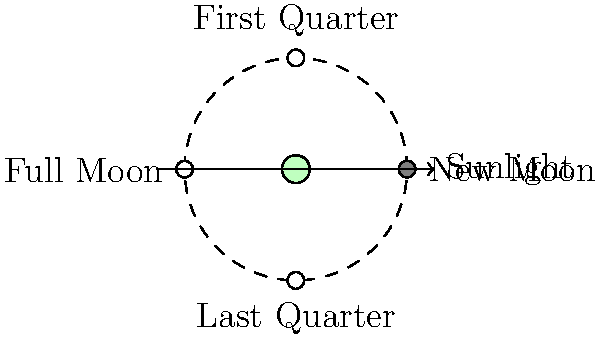As you observe the night sky and connect with the natural rhythms of the Earth, you notice the changing phases of the moon. Based on the diagram, which phase of the moon would occur when the Earth is positioned between the Sun and the Moon? To answer this question, let's break down the moon phases and their relationship to Earth's position:

1. The diagram shows four main phases of the moon: New Moon, First Quarter, Full Moon, and Last Quarter.

2. The arrow on the right indicates the direction of sunlight.

3. The Earth is at the center of the diagram, with the moon's orbit shown as a dashed circle around it.

4. The moon's position relative to Earth and the Sun determines its phase:

   a. New Moon: The moon is between Earth and the Sun, with its dark side facing Earth.
   b. First Quarter: The moon is at a 90-degree angle to the Earth-Sun line, with half of its visible side illuminated.
   c. Full Moon: The Earth is between the Sun and the Moon, with the moon's fully illuminated side facing Earth.
   d. Last Quarter: The moon is again at a 90-degree angle, but on the opposite side from the First Quarter.

5. When the Earth is positioned between the Sun and the Moon, the Sun's light fully illuminates the side of the moon facing Earth.

6. This configuration corresponds to the Full Moon phase in the diagram.

Therefore, when the Earth is positioned between the Sun and the Moon, we observe a Full Moon.
Answer: Full Moon 